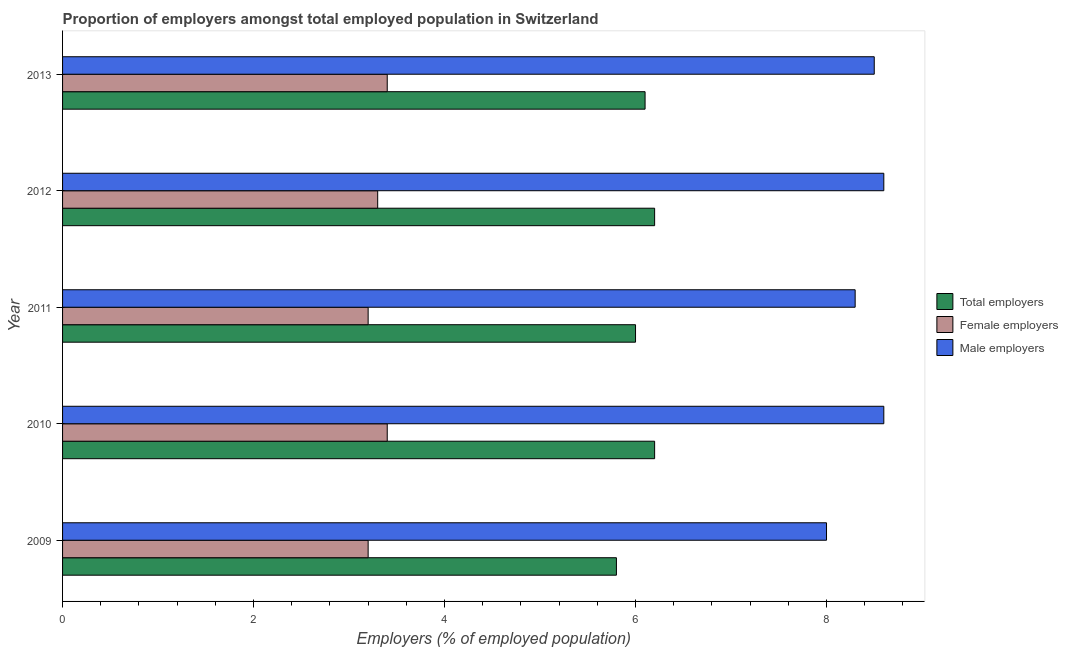How many different coloured bars are there?
Provide a short and direct response. 3. Are the number of bars per tick equal to the number of legend labels?
Your answer should be very brief. Yes. Are the number of bars on each tick of the Y-axis equal?
Your response must be concise. Yes. How many bars are there on the 5th tick from the top?
Offer a very short reply. 3. What is the label of the 1st group of bars from the top?
Give a very brief answer. 2013. What is the percentage of male employers in 2011?
Offer a very short reply. 8.3. Across all years, what is the maximum percentage of total employers?
Ensure brevity in your answer.  6.2. Across all years, what is the minimum percentage of total employers?
Your answer should be compact. 5.8. In which year was the percentage of total employers maximum?
Your response must be concise. 2010. What is the total percentage of female employers in the graph?
Provide a short and direct response. 16.5. What is the difference between the percentage of female employers in 2009 and the percentage of total employers in 2012?
Your response must be concise. -3. In how many years, is the percentage of female employers greater than 2.4 %?
Provide a succinct answer. 5. What is the ratio of the percentage of female employers in 2011 to that in 2013?
Keep it short and to the point. 0.94. Is the percentage of male employers in 2010 less than that in 2011?
Your answer should be compact. No. What is the difference between the highest and the lowest percentage of female employers?
Offer a terse response. 0.2. Is the sum of the percentage of total employers in 2009 and 2011 greater than the maximum percentage of female employers across all years?
Give a very brief answer. Yes. What does the 3rd bar from the top in 2011 represents?
Your answer should be compact. Total employers. What does the 1st bar from the bottom in 2013 represents?
Your answer should be very brief. Total employers. Is it the case that in every year, the sum of the percentage of total employers and percentage of female employers is greater than the percentage of male employers?
Your answer should be very brief. Yes. How many bars are there?
Make the answer very short. 15. Are all the bars in the graph horizontal?
Give a very brief answer. Yes. Are the values on the major ticks of X-axis written in scientific E-notation?
Make the answer very short. No. Does the graph contain any zero values?
Offer a very short reply. No. Where does the legend appear in the graph?
Provide a succinct answer. Center right. How many legend labels are there?
Provide a short and direct response. 3. How are the legend labels stacked?
Give a very brief answer. Vertical. What is the title of the graph?
Your response must be concise. Proportion of employers amongst total employed population in Switzerland. Does "Fuel" appear as one of the legend labels in the graph?
Ensure brevity in your answer.  No. What is the label or title of the X-axis?
Keep it short and to the point. Employers (% of employed population). What is the label or title of the Y-axis?
Your answer should be very brief. Year. What is the Employers (% of employed population) in Total employers in 2009?
Offer a very short reply. 5.8. What is the Employers (% of employed population) in Female employers in 2009?
Offer a very short reply. 3.2. What is the Employers (% of employed population) of Total employers in 2010?
Ensure brevity in your answer.  6.2. What is the Employers (% of employed population) of Female employers in 2010?
Keep it short and to the point. 3.4. What is the Employers (% of employed population) of Male employers in 2010?
Provide a succinct answer. 8.6. What is the Employers (% of employed population) in Total employers in 2011?
Your answer should be compact. 6. What is the Employers (% of employed population) of Female employers in 2011?
Give a very brief answer. 3.2. What is the Employers (% of employed population) in Male employers in 2011?
Your answer should be compact. 8.3. What is the Employers (% of employed population) in Total employers in 2012?
Your answer should be compact. 6.2. What is the Employers (% of employed population) of Female employers in 2012?
Offer a very short reply. 3.3. What is the Employers (% of employed population) in Male employers in 2012?
Your answer should be compact. 8.6. What is the Employers (% of employed population) in Total employers in 2013?
Your response must be concise. 6.1. What is the Employers (% of employed population) in Female employers in 2013?
Make the answer very short. 3.4. What is the Employers (% of employed population) in Male employers in 2013?
Offer a terse response. 8.5. Across all years, what is the maximum Employers (% of employed population) in Total employers?
Offer a very short reply. 6.2. Across all years, what is the maximum Employers (% of employed population) of Female employers?
Give a very brief answer. 3.4. Across all years, what is the maximum Employers (% of employed population) in Male employers?
Offer a very short reply. 8.6. Across all years, what is the minimum Employers (% of employed population) of Total employers?
Make the answer very short. 5.8. Across all years, what is the minimum Employers (% of employed population) of Female employers?
Provide a succinct answer. 3.2. What is the total Employers (% of employed population) of Total employers in the graph?
Make the answer very short. 30.3. What is the total Employers (% of employed population) in Female employers in the graph?
Make the answer very short. 16.5. What is the difference between the Employers (% of employed population) in Female employers in 2009 and that in 2010?
Keep it short and to the point. -0.2. What is the difference between the Employers (% of employed population) in Female employers in 2009 and that in 2011?
Give a very brief answer. 0. What is the difference between the Employers (% of employed population) in Male employers in 2009 and that in 2012?
Offer a very short reply. -0.6. What is the difference between the Employers (% of employed population) in Female employers in 2009 and that in 2013?
Make the answer very short. -0.2. What is the difference between the Employers (% of employed population) in Male employers in 2010 and that in 2011?
Your answer should be compact. 0.3. What is the difference between the Employers (% of employed population) of Total employers in 2010 and that in 2012?
Your answer should be compact. 0. What is the difference between the Employers (% of employed population) of Female employers in 2010 and that in 2012?
Give a very brief answer. 0.1. What is the difference between the Employers (% of employed population) in Male employers in 2010 and that in 2012?
Offer a very short reply. 0. What is the difference between the Employers (% of employed population) of Total employers in 2010 and that in 2013?
Keep it short and to the point. 0.1. What is the difference between the Employers (% of employed population) in Total employers in 2011 and that in 2012?
Ensure brevity in your answer.  -0.2. What is the difference between the Employers (% of employed population) of Female employers in 2011 and that in 2012?
Ensure brevity in your answer.  -0.1. What is the difference between the Employers (% of employed population) in Male employers in 2011 and that in 2013?
Your answer should be compact. -0.2. What is the difference between the Employers (% of employed population) in Total employers in 2012 and that in 2013?
Your answer should be compact. 0.1. What is the difference between the Employers (% of employed population) in Total employers in 2009 and the Employers (% of employed population) in Female employers in 2010?
Provide a succinct answer. 2.4. What is the difference between the Employers (% of employed population) of Female employers in 2009 and the Employers (% of employed population) of Male employers in 2010?
Your response must be concise. -5.4. What is the difference between the Employers (% of employed population) of Female employers in 2009 and the Employers (% of employed population) of Male employers in 2011?
Provide a short and direct response. -5.1. What is the difference between the Employers (% of employed population) of Total employers in 2009 and the Employers (% of employed population) of Female employers in 2012?
Make the answer very short. 2.5. What is the difference between the Employers (% of employed population) in Total employers in 2009 and the Employers (% of employed population) in Male employers in 2012?
Your answer should be very brief. -2.8. What is the difference between the Employers (% of employed population) in Female employers in 2009 and the Employers (% of employed population) in Male employers in 2012?
Provide a succinct answer. -5.4. What is the difference between the Employers (% of employed population) of Total employers in 2009 and the Employers (% of employed population) of Female employers in 2013?
Your answer should be compact. 2.4. What is the difference between the Employers (% of employed population) of Total employers in 2010 and the Employers (% of employed population) of Female employers in 2011?
Your answer should be compact. 3. What is the difference between the Employers (% of employed population) in Total employers in 2010 and the Employers (% of employed population) in Male employers in 2011?
Make the answer very short. -2.1. What is the difference between the Employers (% of employed population) of Female employers in 2010 and the Employers (% of employed population) of Male employers in 2011?
Provide a short and direct response. -4.9. What is the difference between the Employers (% of employed population) in Total employers in 2010 and the Employers (% of employed population) in Female employers in 2012?
Offer a very short reply. 2.9. What is the difference between the Employers (% of employed population) in Female employers in 2010 and the Employers (% of employed population) in Male employers in 2012?
Give a very brief answer. -5.2. What is the difference between the Employers (% of employed population) of Total employers in 2010 and the Employers (% of employed population) of Female employers in 2013?
Offer a very short reply. 2.8. What is the difference between the Employers (% of employed population) in Female employers in 2010 and the Employers (% of employed population) in Male employers in 2013?
Ensure brevity in your answer.  -5.1. What is the difference between the Employers (% of employed population) in Female employers in 2011 and the Employers (% of employed population) in Male employers in 2012?
Your answer should be compact. -5.4. What is the difference between the Employers (% of employed population) in Total employers in 2011 and the Employers (% of employed population) in Female employers in 2013?
Provide a succinct answer. 2.6. What is the difference between the Employers (% of employed population) in Female employers in 2011 and the Employers (% of employed population) in Male employers in 2013?
Offer a terse response. -5.3. What is the difference between the Employers (% of employed population) in Total employers in 2012 and the Employers (% of employed population) in Male employers in 2013?
Give a very brief answer. -2.3. What is the average Employers (% of employed population) of Total employers per year?
Your answer should be very brief. 6.06. What is the average Employers (% of employed population) of Female employers per year?
Make the answer very short. 3.3. What is the average Employers (% of employed population) in Male employers per year?
Keep it short and to the point. 8.4. In the year 2009, what is the difference between the Employers (% of employed population) in Total employers and Employers (% of employed population) in Male employers?
Your response must be concise. -2.2. In the year 2009, what is the difference between the Employers (% of employed population) of Female employers and Employers (% of employed population) of Male employers?
Provide a short and direct response. -4.8. In the year 2010, what is the difference between the Employers (% of employed population) in Total employers and Employers (% of employed population) in Male employers?
Keep it short and to the point. -2.4. In the year 2010, what is the difference between the Employers (% of employed population) in Female employers and Employers (% of employed population) in Male employers?
Provide a short and direct response. -5.2. In the year 2011, what is the difference between the Employers (% of employed population) of Total employers and Employers (% of employed population) of Female employers?
Provide a succinct answer. 2.8. In the year 2012, what is the difference between the Employers (% of employed population) in Total employers and Employers (% of employed population) in Female employers?
Provide a succinct answer. 2.9. In the year 2012, what is the difference between the Employers (% of employed population) of Total employers and Employers (% of employed population) of Male employers?
Your response must be concise. -2.4. What is the ratio of the Employers (% of employed population) of Total employers in 2009 to that in 2010?
Provide a short and direct response. 0.94. What is the ratio of the Employers (% of employed population) of Female employers in 2009 to that in 2010?
Give a very brief answer. 0.94. What is the ratio of the Employers (% of employed population) of Male employers in 2009 to that in 2010?
Offer a terse response. 0.93. What is the ratio of the Employers (% of employed population) of Total employers in 2009 to that in 2011?
Ensure brevity in your answer.  0.97. What is the ratio of the Employers (% of employed population) in Female employers in 2009 to that in 2011?
Give a very brief answer. 1. What is the ratio of the Employers (% of employed population) in Male employers in 2009 to that in 2011?
Your answer should be very brief. 0.96. What is the ratio of the Employers (% of employed population) in Total employers in 2009 to that in 2012?
Offer a terse response. 0.94. What is the ratio of the Employers (% of employed population) in Female employers in 2009 to that in 2012?
Offer a very short reply. 0.97. What is the ratio of the Employers (% of employed population) of Male employers in 2009 to that in 2012?
Provide a succinct answer. 0.93. What is the ratio of the Employers (% of employed population) of Total employers in 2009 to that in 2013?
Give a very brief answer. 0.95. What is the ratio of the Employers (% of employed population) in Total employers in 2010 to that in 2011?
Give a very brief answer. 1.03. What is the ratio of the Employers (% of employed population) of Female employers in 2010 to that in 2011?
Ensure brevity in your answer.  1.06. What is the ratio of the Employers (% of employed population) of Male employers in 2010 to that in 2011?
Ensure brevity in your answer.  1.04. What is the ratio of the Employers (% of employed population) in Female employers in 2010 to that in 2012?
Your answer should be compact. 1.03. What is the ratio of the Employers (% of employed population) of Male employers in 2010 to that in 2012?
Keep it short and to the point. 1. What is the ratio of the Employers (% of employed population) in Total employers in 2010 to that in 2013?
Ensure brevity in your answer.  1.02. What is the ratio of the Employers (% of employed population) in Male employers in 2010 to that in 2013?
Offer a very short reply. 1.01. What is the ratio of the Employers (% of employed population) of Total employers in 2011 to that in 2012?
Your response must be concise. 0.97. What is the ratio of the Employers (% of employed population) of Female employers in 2011 to that in 2012?
Provide a succinct answer. 0.97. What is the ratio of the Employers (% of employed population) of Male employers in 2011 to that in 2012?
Your answer should be very brief. 0.97. What is the ratio of the Employers (% of employed population) of Total employers in 2011 to that in 2013?
Your answer should be very brief. 0.98. What is the ratio of the Employers (% of employed population) of Female employers in 2011 to that in 2013?
Your answer should be very brief. 0.94. What is the ratio of the Employers (% of employed population) in Male employers in 2011 to that in 2013?
Ensure brevity in your answer.  0.98. What is the ratio of the Employers (% of employed population) of Total employers in 2012 to that in 2013?
Your answer should be compact. 1.02. What is the ratio of the Employers (% of employed population) of Female employers in 2012 to that in 2013?
Ensure brevity in your answer.  0.97. What is the ratio of the Employers (% of employed population) of Male employers in 2012 to that in 2013?
Provide a succinct answer. 1.01. What is the difference between the highest and the second highest Employers (% of employed population) of Female employers?
Offer a very short reply. 0. What is the difference between the highest and the lowest Employers (% of employed population) of Female employers?
Your response must be concise. 0.2. 